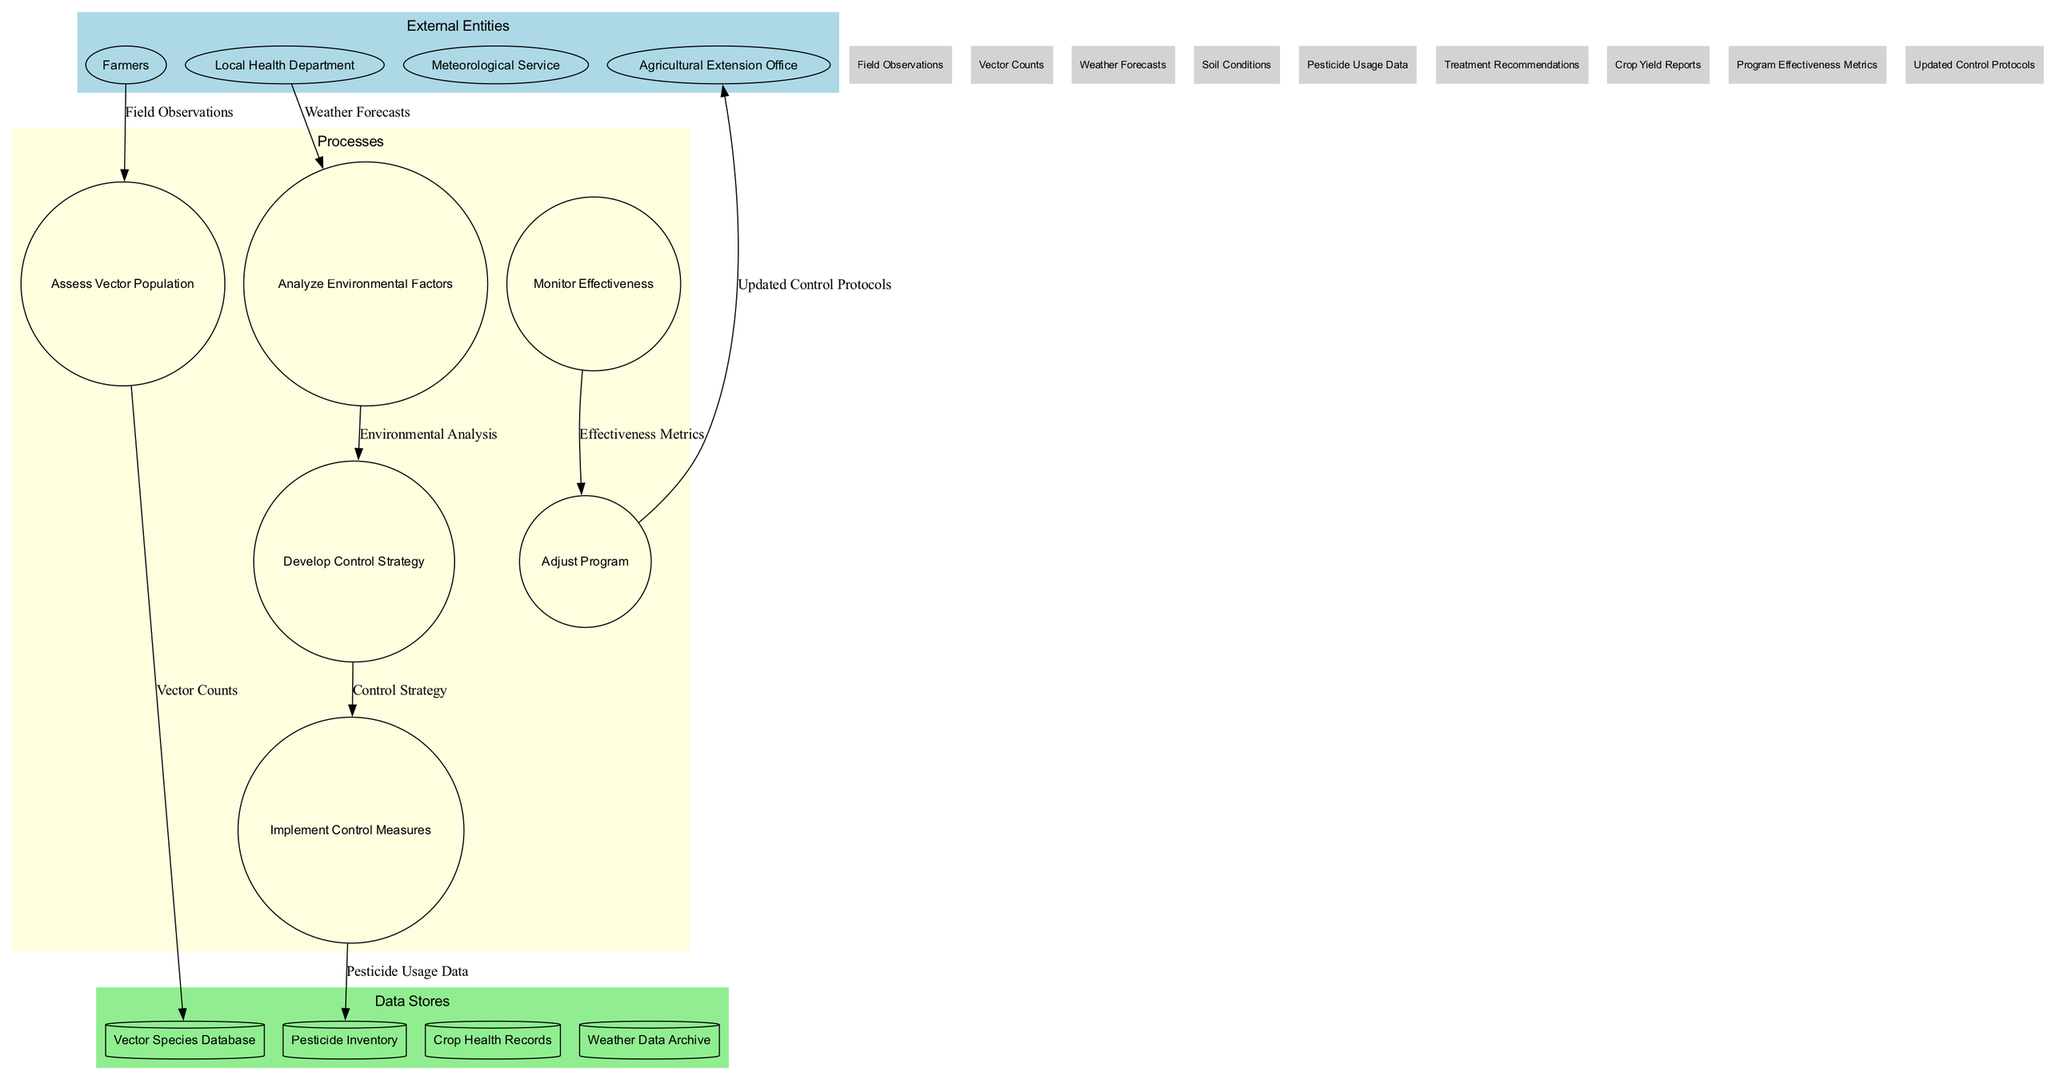What are the external entities in the diagram? The external entities are listed at the top of the diagram, and they include Farmers, Local Health Department, Meteorological Service, and Agricultural Extension Office.
Answer: Farmers, Local Health Department, Meteorological Service, Agricultural Extension Office How many processes are in the diagram? By counting the nodes labeled as processes, we see there are six: Assess Vector Population, Analyze Environmental Factors, Develop Control Strategy, Implement Control Measures, Monitor Effectiveness, and Adjust Program.
Answer: 6 What is the first process in the diagram? The first process is indicated at the beginning of the processes' section, which is Assess Vector Population.
Answer: Assess Vector Population What data flow is linked to the Implement Control Measures process? Upon reviewing the connections of the Implement Control Measures process, the data flow linked to it is categorized as Control Strategy derived from the previous process.
Answer: Control Strategy Which data store is related to Pesticide Usage Data? By examining the edges, we can see that the Implement Control Measures process connects to the Pesticide Inventory data store with the flow of Pesticide Usage Data.
Answer: Pesticide Inventory Which external entity provides Weather Forecasts to the Analyze Environmental Factors process? Weather Forecasts are received from the Meteorological Service, as indicated by the directed flow from that external entity to the corresponding process.
Answer: Meteorological Service What is the final output from the Adjust Program process? The Adjust Program process outputs the updated control protocols to the Agricultural Extension Office external entity, as shown by the directed edge leading from the process.
Answer: Updated Control Protocols How many data flows are present in the diagram? Counting the flows listed shows there are nine data flows: Field Observations, Vector Counts, Weather Forecasts, Soil Conditions, Pesticide Usage Data, Treatment Recommendations, Crop Yield Reports, Program Effectiveness Metrics, and Updated Control Protocols.
Answer: 9 Which process directly follows the Analyze Environmental Factors? Following the flow from the Analyze Environmental Factors process leads us directly to the Develop Control Strategy process, indicating its sequential order.
Answer: Develop Control Strategy 